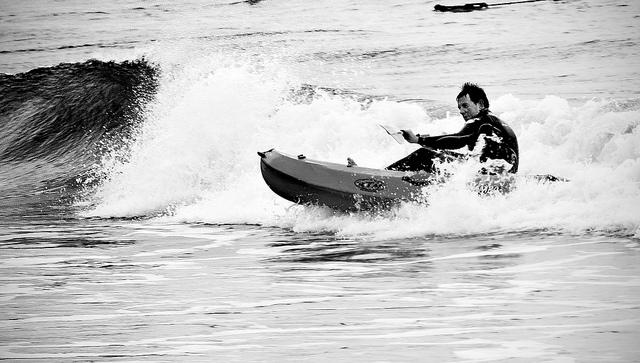Can the person stand on this water equipment while in the water?
Be succinct. Yes. Is he wearing a wetsuit?
Write a very short answer. Yes. Is this person surfing?
Answer briefly. No. 